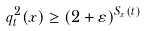<formula> <loc_0><loc_0><loc_500><loc_500>q ^ { 2 } _ { t } ( x ) \geq ( 2 + \varepsilon ) ^ { S _ { x } ( t ) }</formula> 